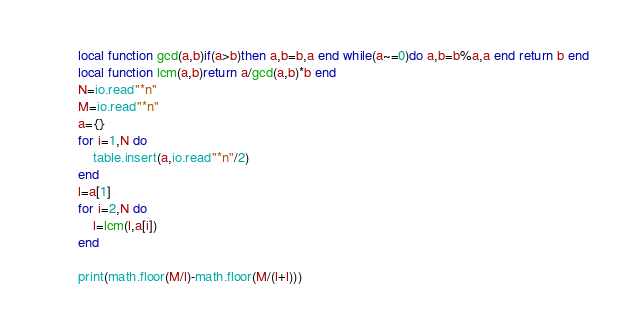<code> <loc_0><loc_0><loc_500><loc_500><_Lua_>local function gcd(a,b)if(a>b)then a,b=b,a end while(a~=0)do a,b=b%a,a end return b end
local function lcm(a,b)return a/gcd(a,b)*b end
N=io.read"*n"
M=io.read"*n"
a={}
for i=1,N do
	table.insert(a,io.read"*n"/2)
end
l=a[1]
for i=2,N do
	l=lcm(l,a[i])
end

print(math.floor(M/l)-math.floor(M/(l+l)))</code> 